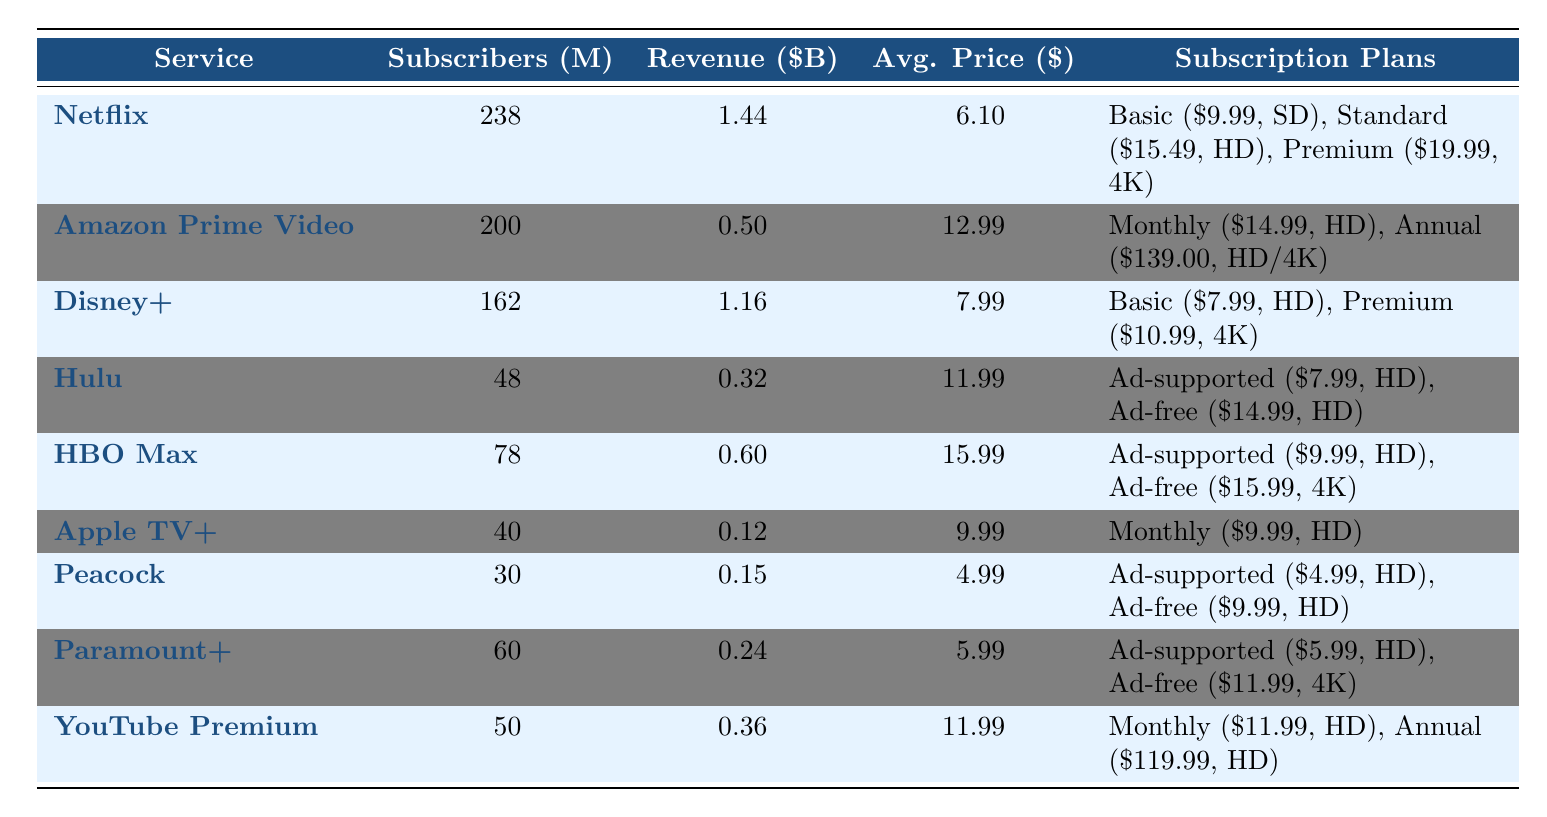What is the total number of subscribers across all services? By adding up the total subscribers for each service: 238 (Netflix) + 200 (Amazon Prime Video) + 162 (Disney+) + 48 (Hulu) + 78 (HBO Max) + 40 (Apple TV+) + 30 (Peacock) + 60 (Paramount+) + 50 (YouTube Premium) =  886 million.
Answer: 886 million Which service has the highest average subscription price? Comparing the average prices listed: Netflix ($6.10), Amazon Prime Video ($12.99), Disney+ ($7.99), Hulu ($11.99), HBO Max ($15.99), Apple TV+ ($9.99), Peacock ($4.99), Paramount+ ($5.99), YouTube Premium ($11.99), HBO Max has the highest at $15.99.
Answer: HBO Max How much revenue does Hulu generate per month? The table indicates that Hulu generates $0.32 billion per month.
Answer: $0.32 billion Which service has the least number of subscribers? Looking at the total subscribers column, Peacock has 30 million subscribers, the lowest among all services.
Answer: Peacock What is the average subscription price of all services combined? First, sum up the average prices: $6.10 (Netflix) + $12.99 (Amazon Prime Video) + $7.99 (Disney+) + $11.99 (Hulu) + $15.99 (HBO Max) + $9.99 (Apple TV+) + $4.99 (Peacock) + $5.99 (Paramount+) + $11.99 (YouTube Premium) = $92.02. Dividing this sum by the number of services (9) gives an average of $10.22.
Answer: $10.22 Which plan from Netflix offers the highest resolution? Among Netflix's plans, the Premium plan offers a resolution of 4K, whereas Basic and Standard provide SD and HD resolutions respectively.
Answer: Premium Plan True or False: Disney+ has a Basic plan priced lower than $8.00. The Basic plan for Disney+ is priced at $7.99, which is not lower than $8.00. Therefore, the statement is False.
Answer: False How much revenue does the service with the highest number of subscribers generate per month? Netflix, with the highest subscribers (238 million), generates $1.44 billion per month according to the table.
Answer: $1.44 billion What is the price difference between the Ad-supported and Ad-free plans for Hulu? The Ad-supported plan costs $7.99, and the Ad-free plan costs $14.99; thus, the difference is $14.99 - $7.99 = $7.00.
Answer: $7.00 Considering all subscription plans, which service offers a monthly plan under $10.00? Peacock has an Ad-supported plan priced at $4.99, and Apple TV+ offers a plan at $9.99. Both are below $10.00.
Answer: Peacock and Apple TV+ Which streaming service has both monthly and annual subscription plans? Amazon Prime Video offers both a monthly ($14.99) and an annual ($139.00) subscription plan according to the table.
Answer: Amazon Prime Video 